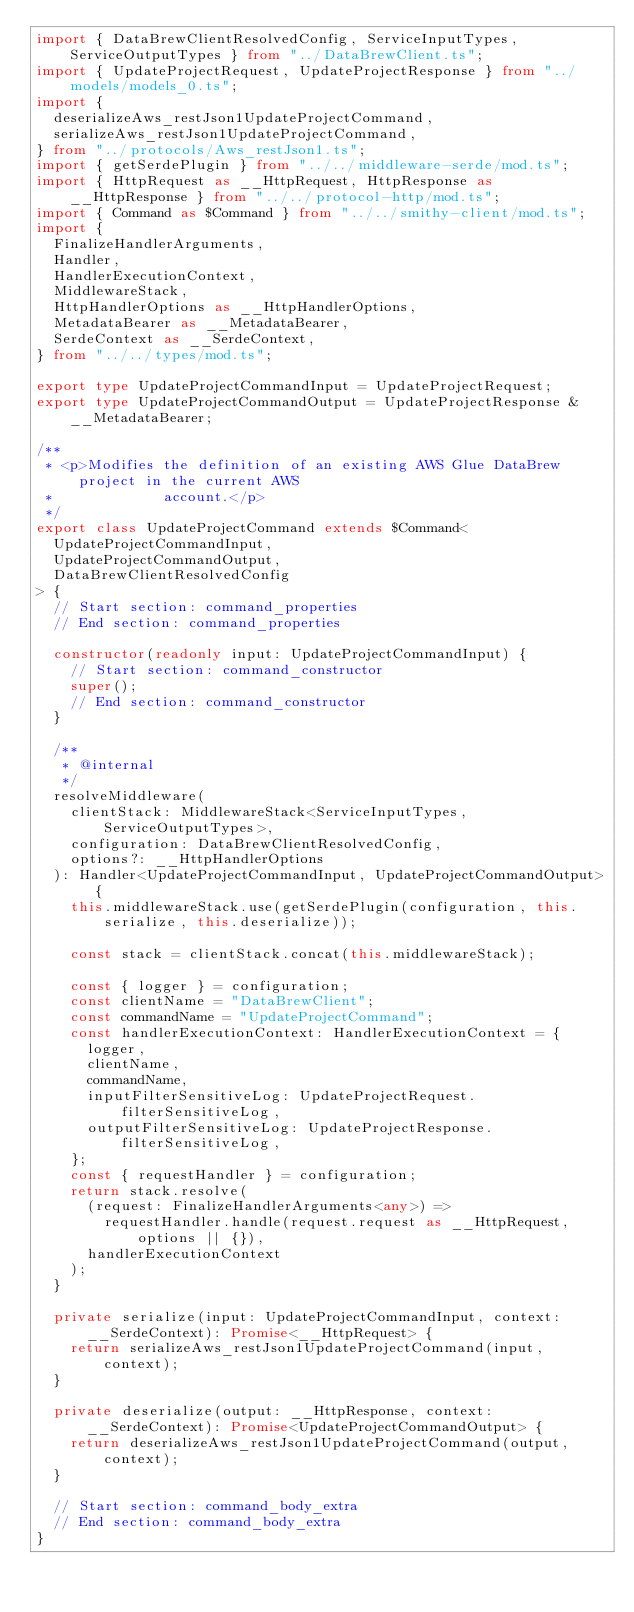<code> <loc_0><loc_0><loc_500><loc_500><_TypeScript_>import { DataBrewClientResolvedConfig, ServiceInputTypes, ServiceOutputTypes } from "../DataBrewClient.ts";
import { UpdateProjectRequest, UpdateProjectResponse } from "../models/models_0.ts";
import {
  deserializeAws_restJson1UpdateProjectCommand,
  serializeAws_restJson1UpdateProjectCommand,
} from "../protocols/Aws_restJson1.ts";
import { getSerdePlugin } from "../../middleware-serde/mod.ts";
import { HttpRequest as __HttpRequest, HttpResponse as __HttpResponse } from "../../protocol-http/mod.ts";
import { Command as $Command } from "../../smithy-client/mod.ts";
import {
  FinalizeHandlerArguments,
  Handler,
  HandlerExecutionContext,
  MiddlewareStack,
  HttpHandlerOptions as __HttpHandlerOptions,
  MetadataBearer as __MetadataBearer,
  SerdeContext as __SerdeContext,
} from "../../types/mod.ts";

export type UpdateProjectCommandInput = UpdateProjectRequest;
export type UpdateProjectCommandOutput = UpdateProjectResponse & __MetadataBearer;

/**
 * <p>Modifies the definition of an existing AWS Glue DataBrew project in the current AWS
 *             account.</p>
 */
export class UpdateProjectCommand extends $Command<
  UpdateProjectCommandInput,
  UpdateProjectCommandOutput,
  DataBrewClientResolvedConfig
> {
  // Start section: command_properties
  // End section: command_properties

  constructor(readonly input: UpdateProjectCommandInput) {
    // Start section: command_constructor
    super();
    // End section: command_constructor
  }

  /**
   * @internal
   */
  resolveMiddleware(
    clientStack: MiddlewareStack<ServiceInputTypes, ServiceOutputTypes>,
    configuration: DataBrewClientResolvedConfig,
    options?: __HttpHandlerOptions
  ): Handler<UpdateProjectCommandInput, UpdateProjectCommandOutput> {
    this.middlewareStack.use(getSerdePlugin(configuration, this.serialize, this.deserialize));

    const stack = clientStack.concat(this.middlewareStack);

    const { logger } = configuration;
    const clientName = "DataBrewClient";
    const commandName = "UpdateProjectCommand";
    const handlerExecutionContext: HandlerExecutionContext = {
      logger,
      clientName,
      commandName,
      inputFilterSensitiveLog: UpdateProjectRequest.filterSensitiveLog,
      outputFilterSensitiveLog: UpdateProjectResponse.filterSensitiveLog,
    };
    const { requestHandler } = configuration;
    return stack.resolve(
      (request: FinalizeHandlerArguments<any>) =>
        requestHandler.handle(request.request as __HttpRequest, options || {}),
      handlerExecutionContext
    );
  }

  private serialize(input: UpdateProjectCommandInput, context: __SerdeContext): Promise<__HttpRequest> {
    return serializeAws_restJson1UpdateProjectCommand(input, context);
  }

  private deserialize(output: __HttpResponse, context: __SerdeContext): Promise<UpdateProjectCommandOutput> {
    return deserializeAws_restJson1UpdateProjectCommand(output, context);
  }

  // Start section: command_body_extra
  // End section: command_body_extra
}
</code> 